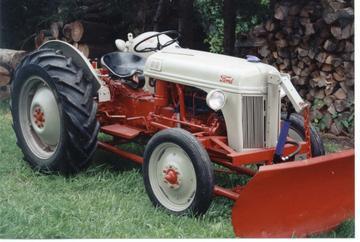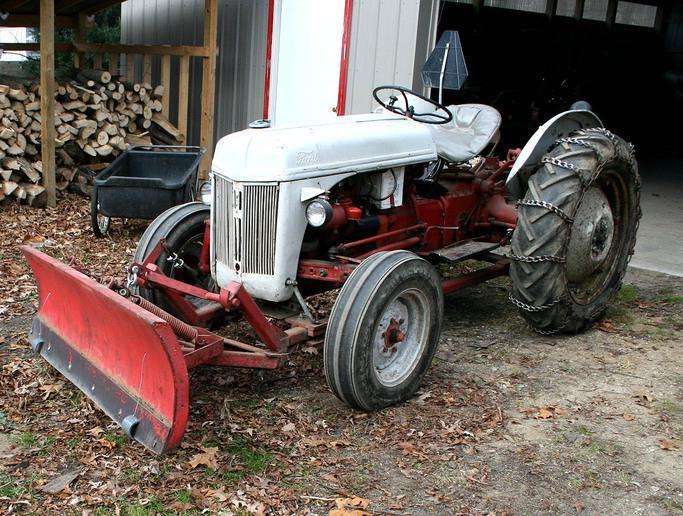The first image is the image on the left, the second image is the image on the right. Assess this claim about the two images: "Right image shows a tractor with plow on a snow-covered ground.". Correct or not? Answer yes or no. No. The first image is the image on the left, the second image is the image on the right. Assess this claim about the two images: "there are two trees in the image on the right.". Correct or not? Answer yes or no. No. 